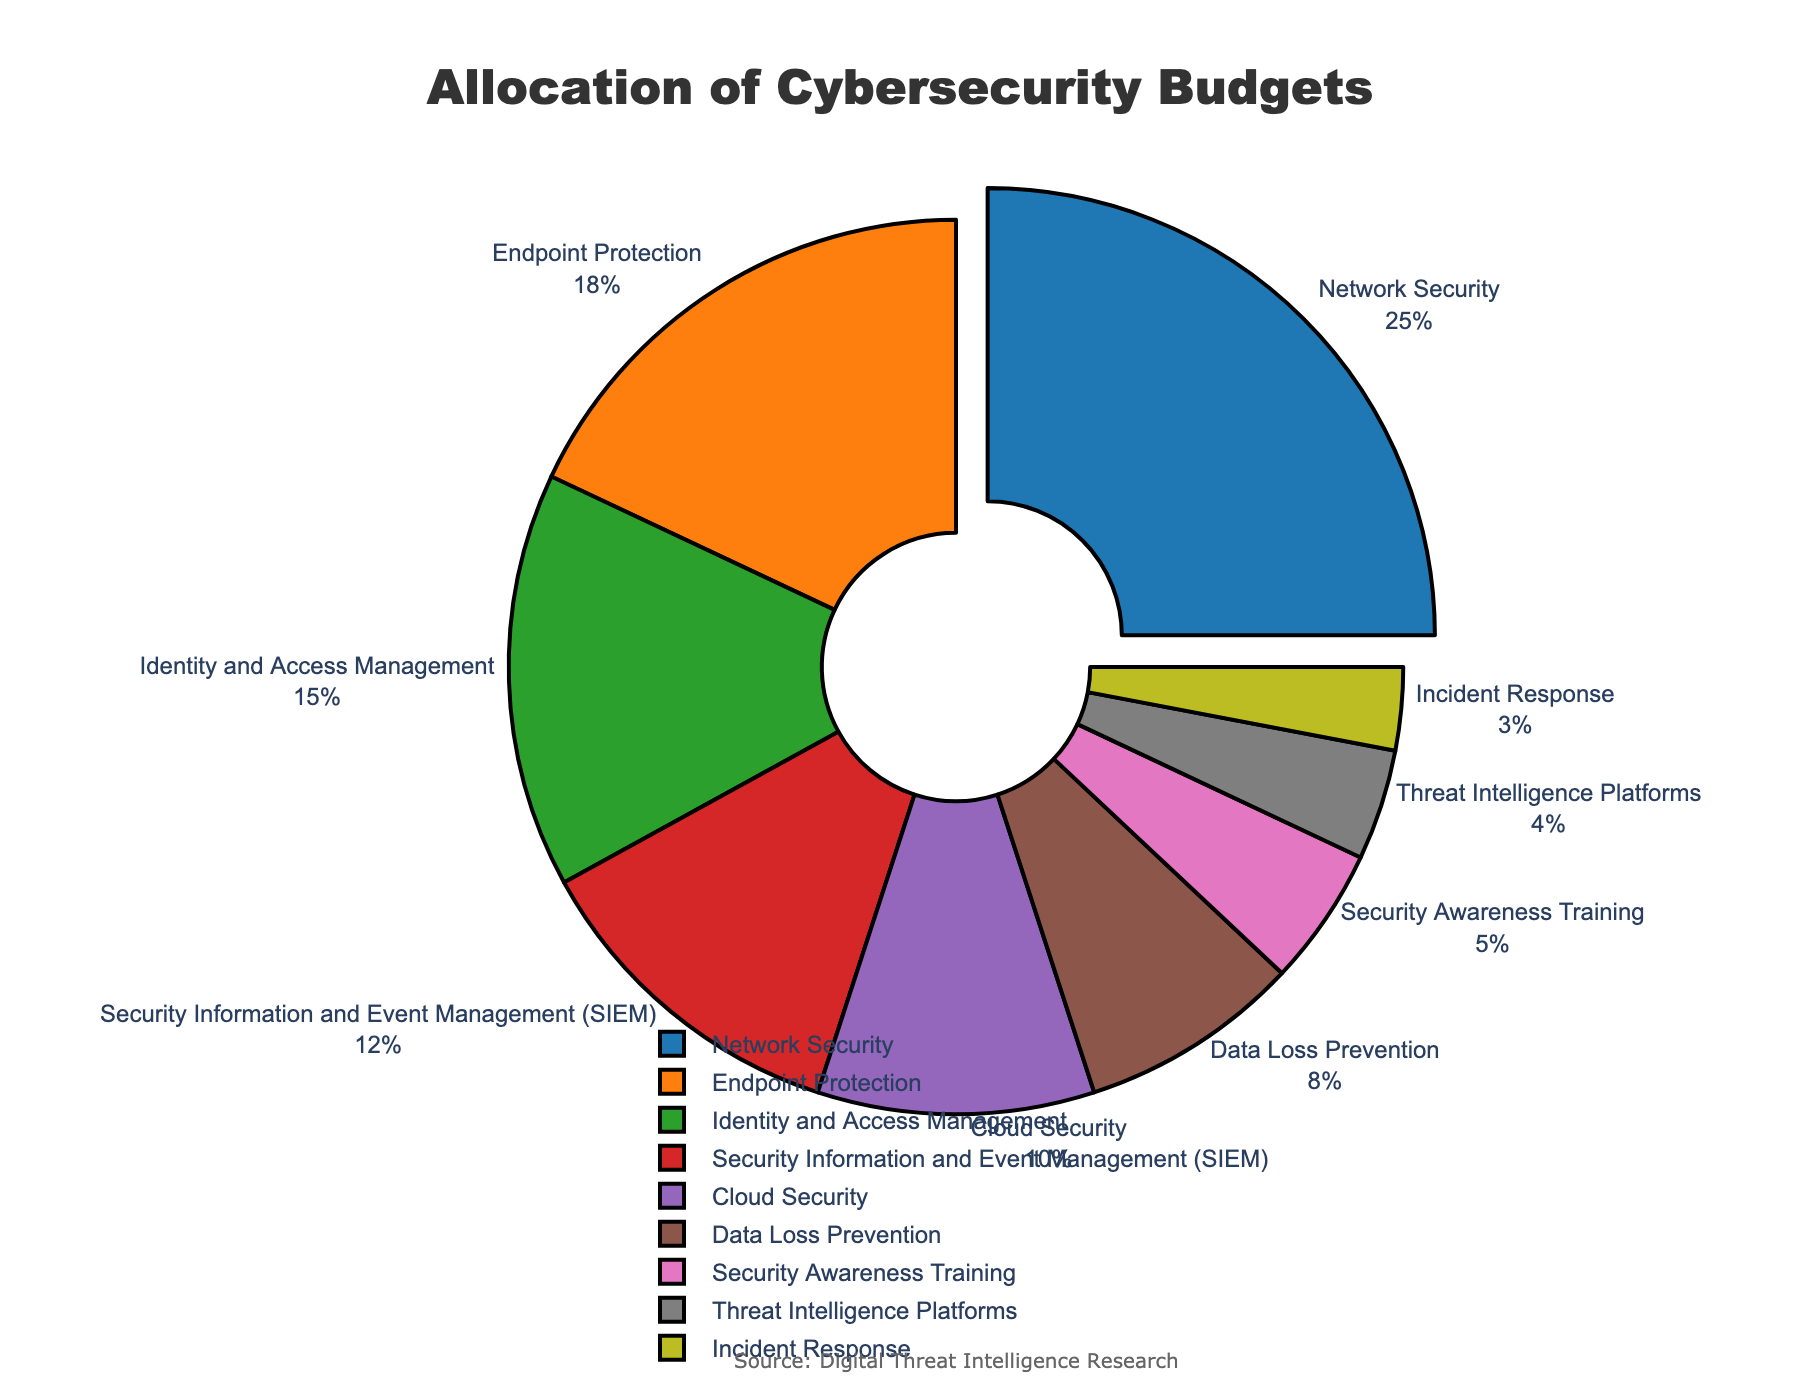What is the category with the highest percentage allocation? The pie chart indicates that 'Network Security' has the largest segment, which is explicitly highlighted by being slightly pulled out from the rest, showing a 25% allocation.
Answer: Network Security What is the total percentage allocation for Endpoint Protection and Cloud Security categories combined? The percentage allocation for Endpoint Protection is 18% and for Cloud Security is 10%. Adding these two values gives us 28%.
Answer: 28% Which category has the smallest allocation, and what is its percentage? The smallest segment in the pie chart is 'Incident Response,’ indicated by its visual size and the percentage label showing 3%.
Answer: Incident Response, 3% How much more percentage is allocated to Network Security compared to Identity and Access Management? Network Security is allocated 25%, and Identity and Access Management is allocated 15%. The difference is 25% - 15% = 10%.
Answer: 10% What is the percentage difference between Data Loss Prevention and Security Awareness Training? The percentage allocation for Data Loss Prevention is 8%, and for Security Awareness Training, it is 5%. The difference is 8% - 5% = 3%.
Answer: 3% Which category is allocated exactly 18% of the budget? The pie chart shows that 'Endpoint Protection' has a segment labeled with 18%.
Answer: Endpoint Protection What percentage of the budget is allocated to measures that are aimed at direct protection of assets (Network Security, Endpoint Protection, Cloud Security)? The individual allocations are Network Security (25%), Endpoint Protection (18%), and Cloud Security (10%). Summing these gives 25% + 18% + 10% = 53%.
Answer: 53% Compare the sum of percentages for Identity and Access Management and SIEM with the percentage for Network Security. Which is larger, and by how much? The sum of Identity and Access Management (15%) and SIEM (12%) is 15% + 12% = 27%. Network Security has 25%. The comparison shows 27% is larger than 25% by 2%.
Answer: Identity and Access Management + SIEM, 2% What categories form the smallest quartile in terms of budget allocation? To find the smallest quartile, we order the percentages: 3%, 4%, 5%, 8%, 10%, 12%, 15%, 18%, 25%. The smallest quartile would be the values below the 25th percentile, so the smallest quarter of categories are Incident Response (3%), Threat Intelligence Platforms (4%), Security Awareness Training (5%).
Answer: Incident Response, Threat Intelligence Platforms, Security Awareness Training If you were to double the budget allocation for Security Awareness Training, what would be the new percentage? The current allocation for Security Awareness Training is 5%. Doubling this would result in 5% * 2 = 10%.
Answer: 10% 